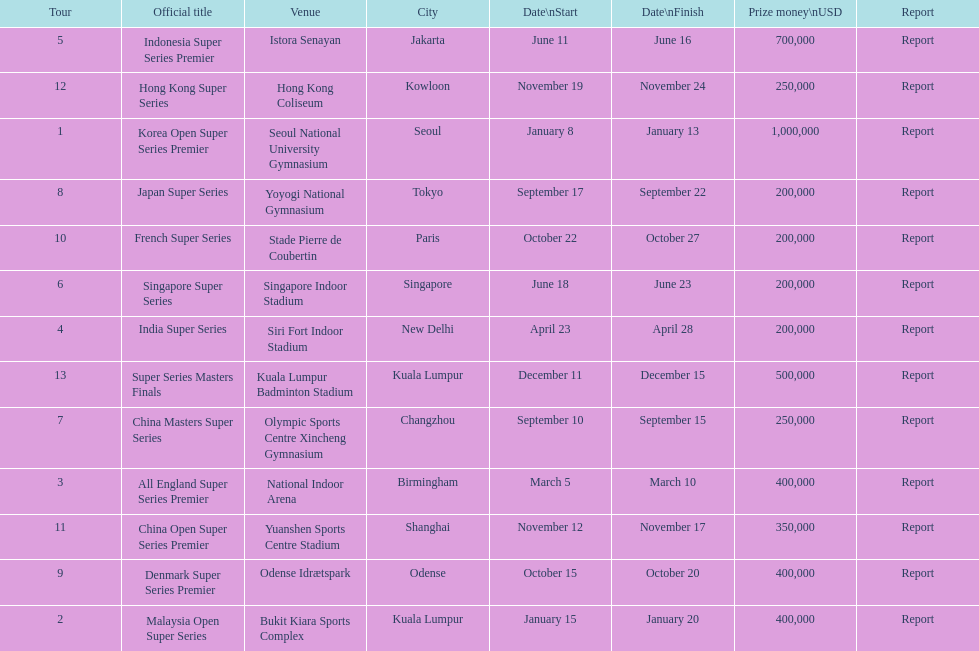How many events of the 2013 bwf super series pay over $200,000? 9. 